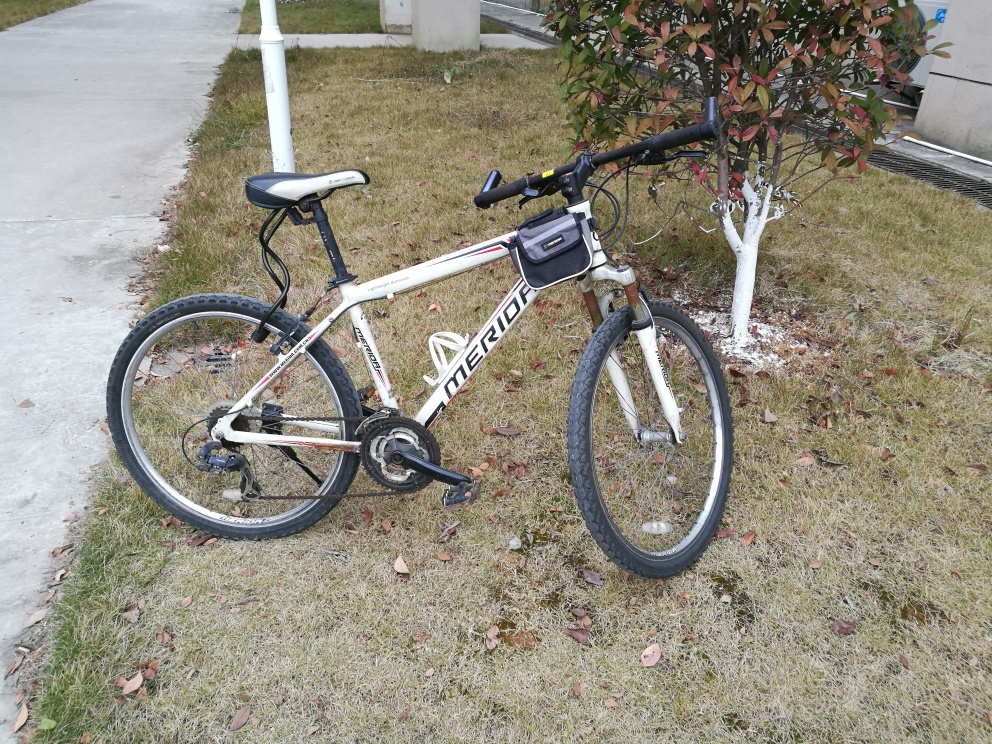Can you describe the environment in which the bike is located? The bike is parked in an outdoor setting, likely a park or garden given the presence of maintained grass and a small tree. There is a paved path next to the bike, and the tree behind it has been painted at the base, which is often done to protect the tree's bark or to indicate that the area is cared for by municipal services. What can you infer about the owner or usage of the bike? Given the bike's condition and the casual way it is parked against the tree, it might belong to someone who uses it for leisurely rides rather than competitive mountain biking. Additionally, the presence of a phone or GPS mount on the handlebars suggests that the owner uses it for navigation or tracking their rides, which could imply a degree of regular use or interest in riding routes. 